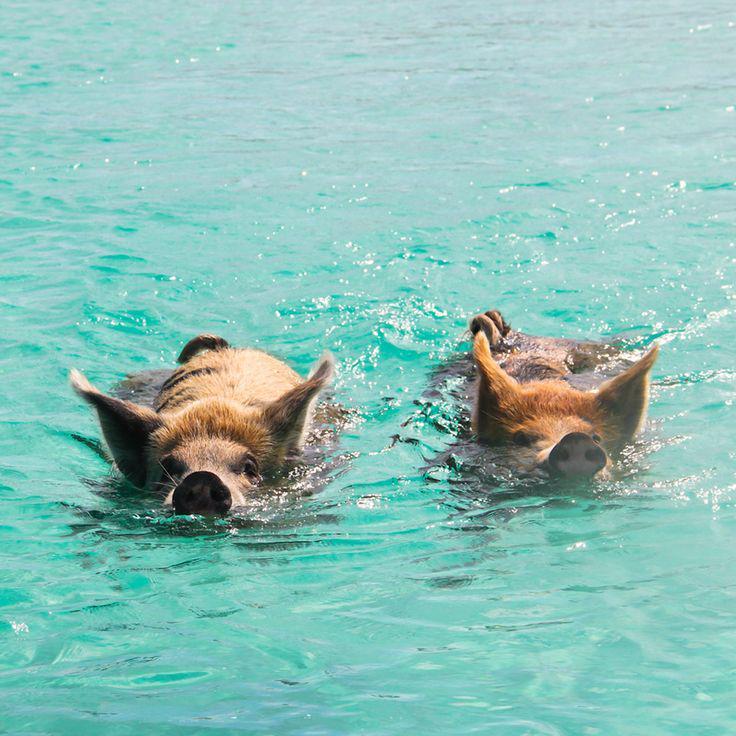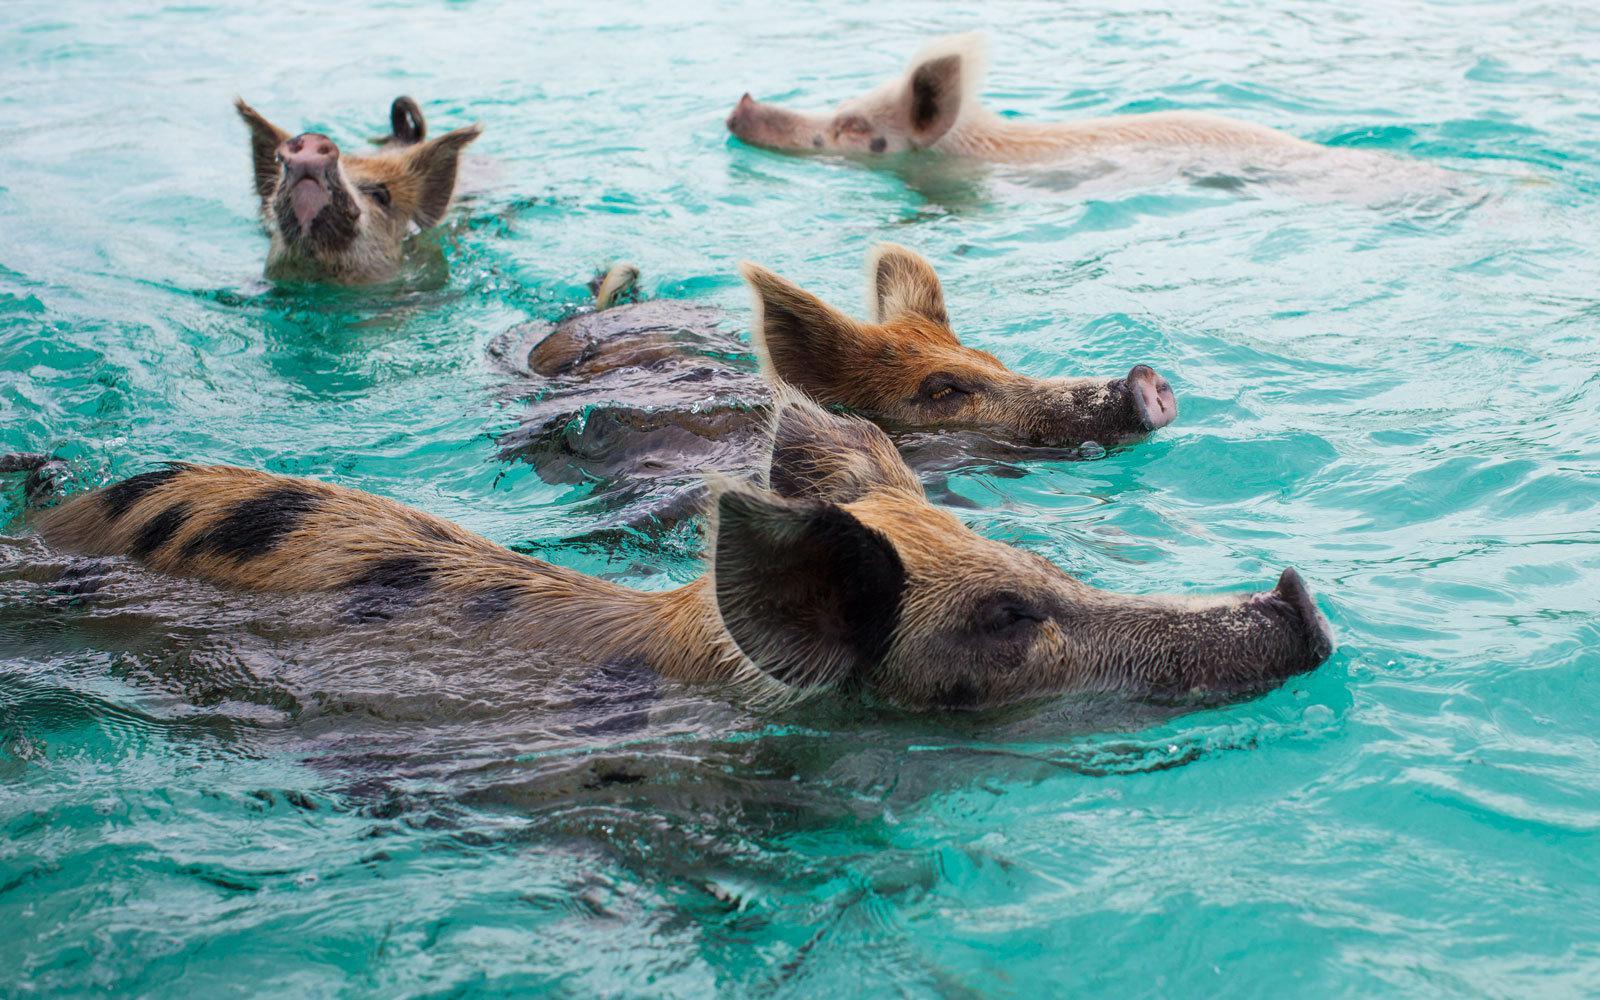The first image is the image on the left, the second image is the image on the right. Evaluate the accuracy of this statement regarding the images: "The right image contains exactly one spotted pig, which is viewed from above and swimming toward the camera.". Is it true? Answer yes or no. No. The first image is the image on the left, the second image is the image on the right. Assess this claim about the two images: "There is one pig in the right image.". Correct or not? Answer yes or no. No. 